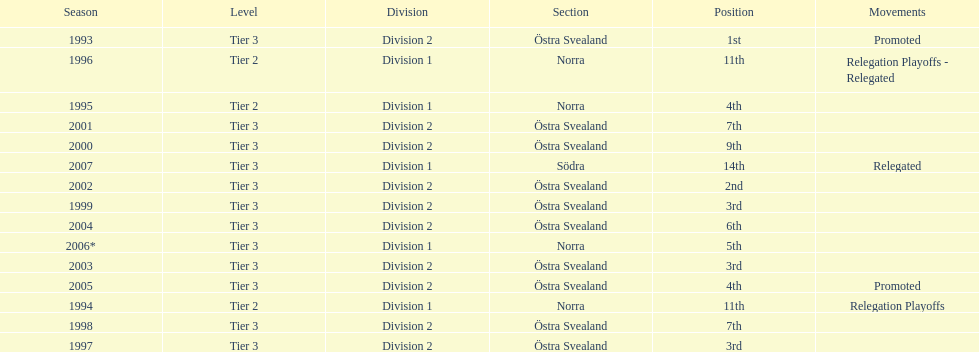What year is at least on the list? 2007. 